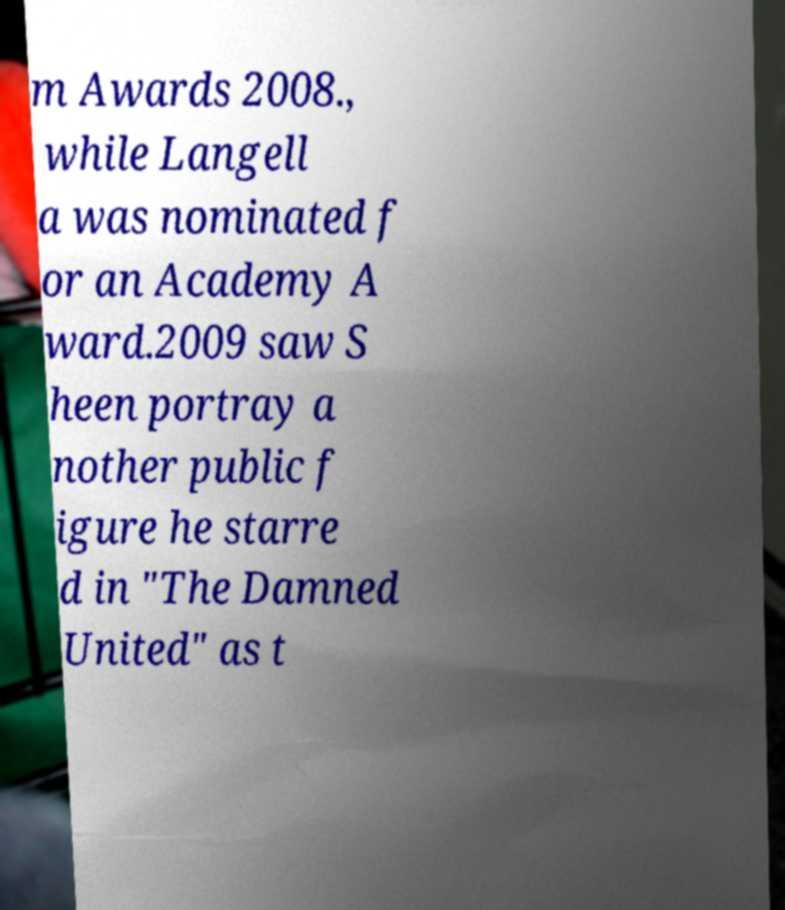Could you extract and type out the text from this image? m Awards 2008., while Langell a was nominated f or an Academy A ward.2009 saw S heen portray a nother public f igure he starre d in "The Damned United" as t 